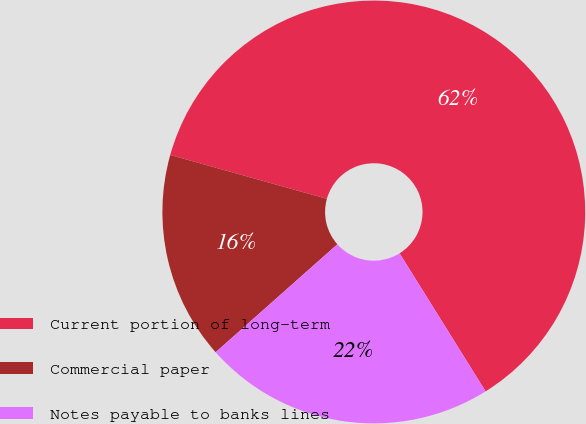Convert chart. <chart><loc_0><loc_0><loc_500><loc_500><pie_chart><fcel>Current portion of long-term<fcel>Commercial paper<fcel>Notes payable to banks lines<nl><fcel>61.78%<fcel>15.89%<fcel>22.32%<nl></chart> 